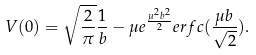Convert formula to latex. <formula><loc_0><loc_0><loc_500><loc_500>V ( 0 ) = \sqrt { \frac { 2 } { \pi } } \frac { 1 } { b } - \mu e ^ { \frac { \mu ^ { 2 } b ^ { 2 } } { 2 } } e r f c ( \frac { \mu b } { \sqrt { 2 } } ) .</formula> 